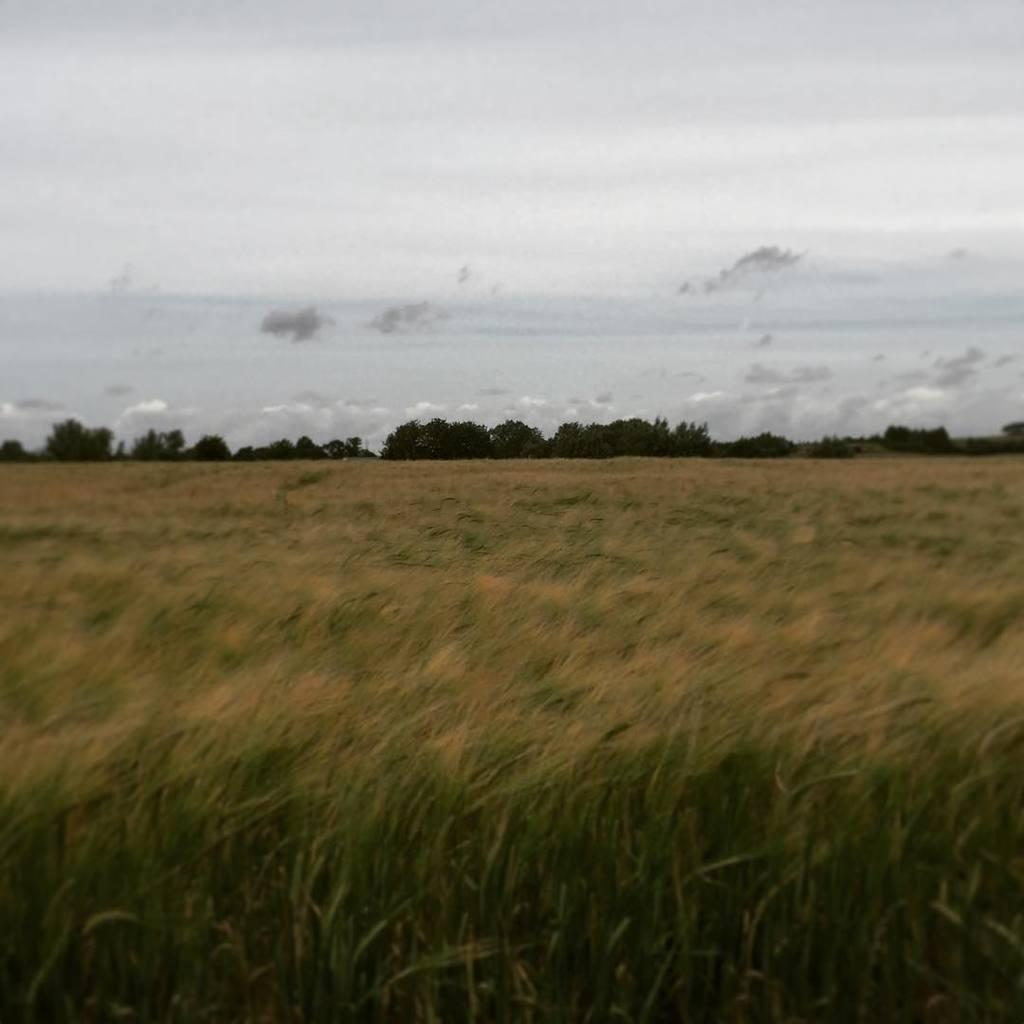What type of vegetation is visible in the front of the image? There is dry grass in the front of the image. What can be seen in the background of the image? There are trees in the background of the image. How would you describe the sky in the image? The sky is cloudy in the image. What invention is being judged by the crib in the image? There is no invention or crib present in the image; it features dry grass, trees, and a cloudy sky. 